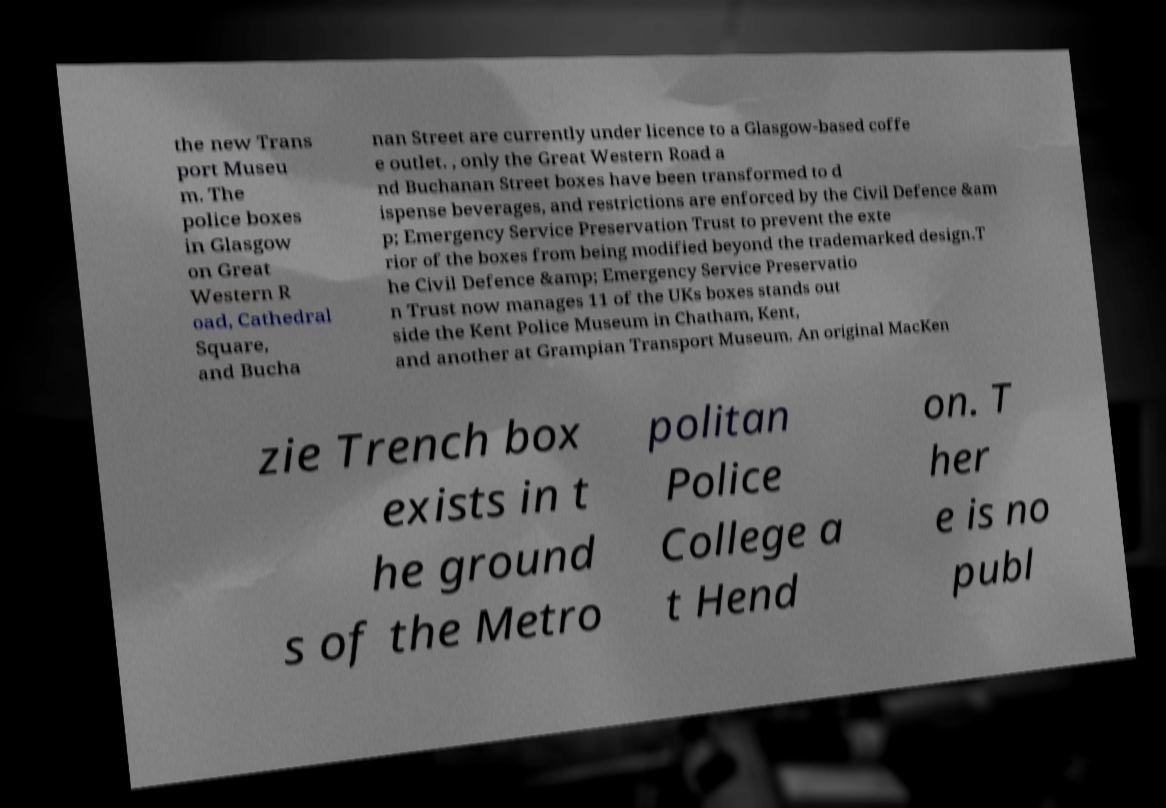For documentation purposes, I need the text within this image transcribed. Could you provide that? the new Trans port Museu m. The police boxes in Glasgow on Great Western R oad, Cathedral Square, and Bucha nan Street are currently under licence to a Glasgow-based coffe e outlet. , only the Great Western Road a nd Buchanan Street boxes have been transformed to d ispense beverages, and restrictions are enforced by the Civil Defence &am p; Emergency Service Preservation Trust to prevent the exte rior of the boxes from being modified beyond the trademarked design.T he Civil Defence &amp; Emergency Service Preservatio n Trust now manages 11 of the UKs boxes stands out side the Kent Police Museum in Chatham, Kent, and another at Grampian Transport Museum. An original MacKen zie Trench box exists in t he ground s of the Metro politan Police College a t Hend on. T her e is no publ 